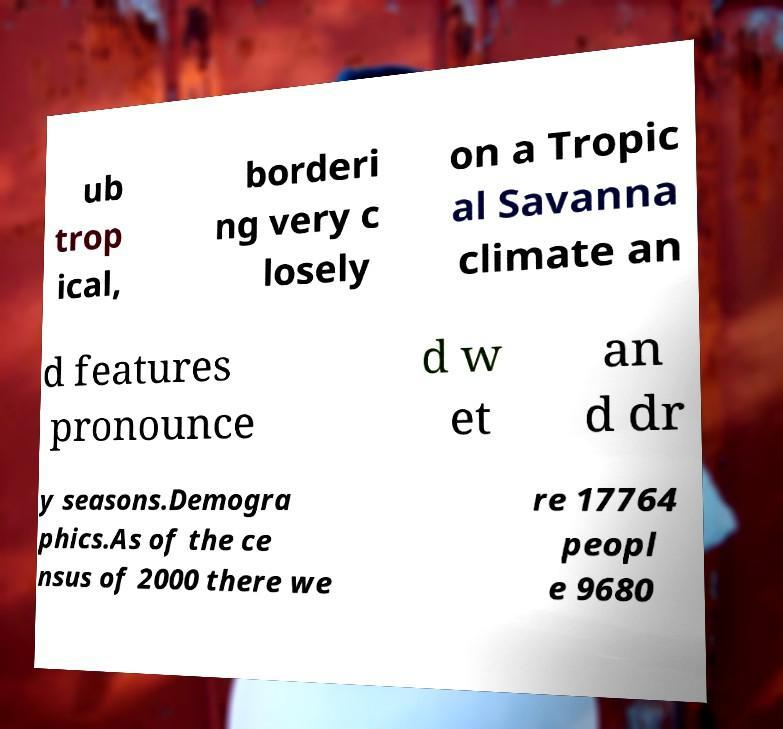Could you extract and type out the text from this image? ub trop ical, borderi ng very c losely on a Tropic al Savanna climate an d features pronounce d w et an d dr y seasons.Demogra phics.As of the ce nsus of 2000 there we re 17764 peopl e 9680 